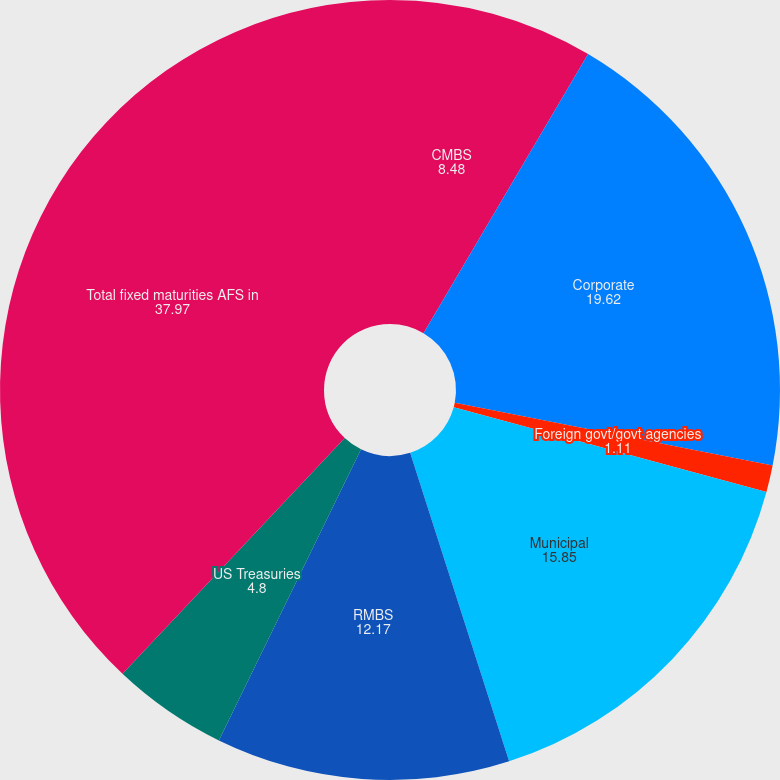Convert chart. <chart><loc_0><loc_0><loc_500><loc_500><pie_chart><fcel>CMBS<fcel>Corporate<fcel>Foreign govt/govt agencies<fcel>Municipal<fcel>RMBS<fcel>US Treasuries<fcel>Total fixed maturities AFS in<nl><fcel>8.48%<fcel>19.62%<fcel>1.11%<fcel>15.85%<fcel>12.17%<fcel>4.8%<fcel>37.97%<nl></chart> 